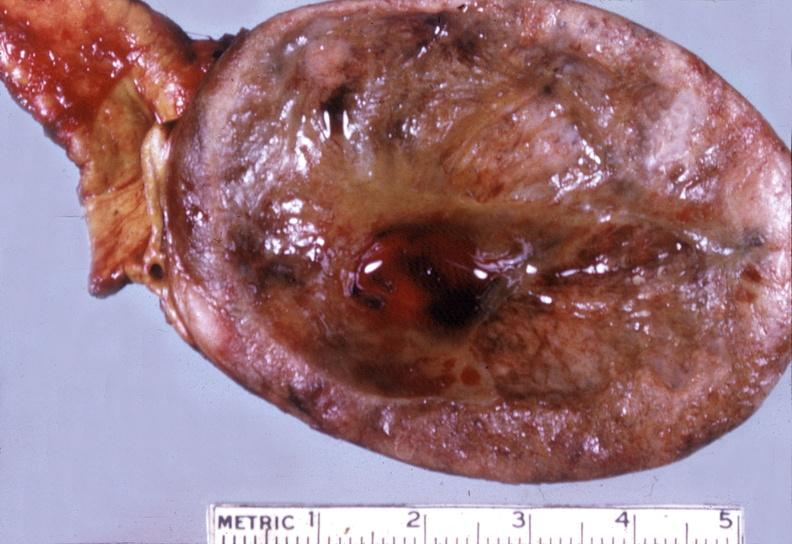does this image show adrenal, pheochromocytoma?
Answer the question using a single word or phrase. Yes 